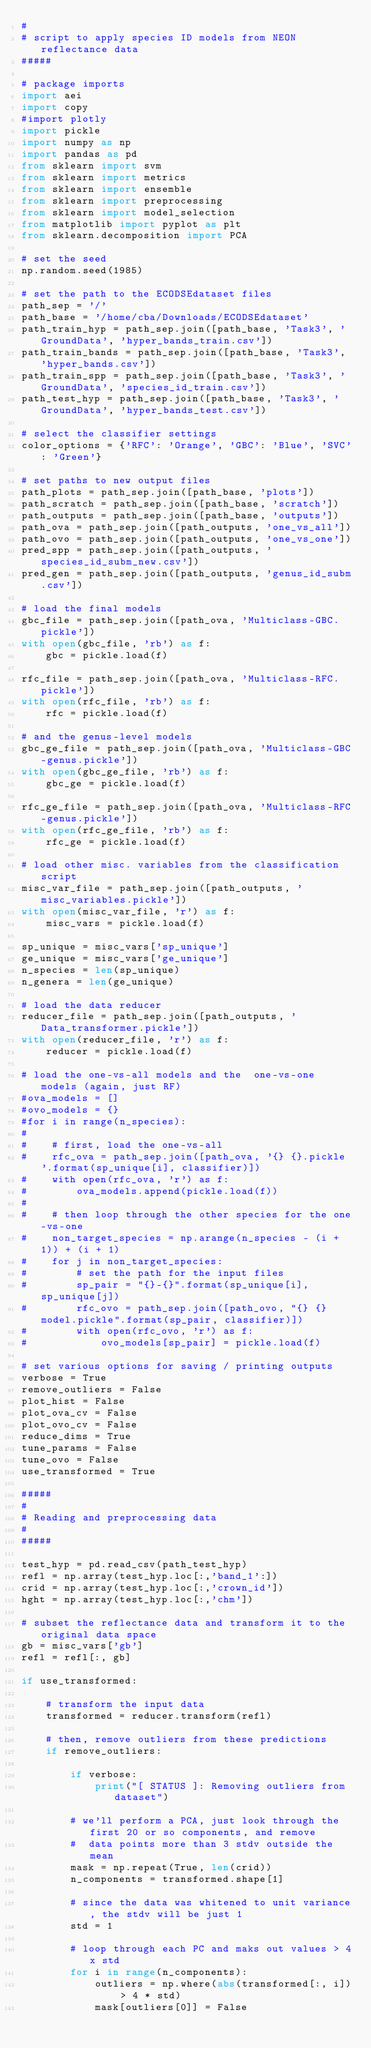Convert code to text. <code><loc_0><loc_0><loc_500><loc_500><_Python_>#
# script to apply species ID models from NEON reflectance data
#####

# package imports
import aei
import copy
#import plotly
import pickle
import numpy as np
import pandas as pd
from sklearn import svm
from sklearn import metrics
from sklearn import ensemble
from sklearn import preprocessing
from sklearn import model_selection
from matplotlib import pyplot as plt
from sklearn.decomposition import PCA

# set the seed
np.random.seed(1985)

# set the path to the ECODSEdataset files
path_sep = '/'
path_base = '/home/cba/Downloads/ECODSEdataset'
path_train_hyp = path_sep.join([path_base, 'Task3', 'GroundData', 'hyper_bands_train.csv'])
path_train_bands = path_sep.join([path_base, 'Task3', 'hyper_bands.csv'])
path_train_spp = path_sep.join([path_base, 'Task3', 'GroundData', 'species_id_train.csv'])
path_test_hyp = path_sep.join([path_base, 'Task3', 'GroundData', 'hyper_bands_test.csv'])

# select the classifier settings
color_options = {'RFC': 'Orange', 'GBC': 'Blue', 'SVC': 'Green'}

# set paths to new output files
path_plots = path_sep.join([path_base, 'plots'])
path_scratch = path_sep.join([path_base, 'scratch'])
path_outputs = path_sep.join([path_base, 'outputs'])
path_ova = path_sep.join([path_outputs, 'one_vs_all'])
path_ovo = path_sep.join([path_outputs, 'one_vs_one'])
pred_spp = path_sep.join([path_outputs, 'species_id_subm_new.csv'])
pred_gen = path_sep.join([path_outputs, 'genus_id_subm.csv'])

# load the final models
gbc_file = path_sep.join([path_ova, 'Multiclass-GBC.pickle'])
with open(gbc_file, 'rb') as f:
    gbc = pickle.load(f)

rfc_file = path_sep.join([path_ova, 'Multiclass-RFC.pickle'])
with open(rfc_file, 'rb') as f:
    rfc = pickle.load(f)
    
# and the genus-level models
gbc_ge_file = path_sep.join([path_ova, 'Multiclass-GBC-genus.pickle'])
with open(gbc_ge_file, 'rb') as f:
    gbc_ge = pickle.load(f)

rfc_ge_file = path_sep.join([path_ova, 'Multiclass-RFC-genus.pickle'])
with open(rfc_ge_file, 'rb') as f:
    rfc_ge = pickle.load(f)
    
# load other misc. variables from the classification script
misc_var_file = path_sep.join([path_outputs, 'misc_variables.pickle'])
with open(misc_var_file, 'r') as f:
    misc_vars = pickle.load(f)
    
sp_unique = misc_vars['sp_unique']
ge_unique = misc_vars['ge_unique']
n_species = len(sp_unique)
n_genera = len(ge_unique)

# load the data reducer
reducer_file = path_sep.join([path_outputs, 'Data_transformer.pickle'])
with open(reducer_file, 'r') as f:
    reducer = pickle.load(f)
    
# load the one-vs-all models and the  one-vs-one models (again, just RF)
#ova_models = []
#ovo_models = {}
#for i in range(n_species):
#    
#    # first, load the one-vs-all
#    rfc_ova = path_sep.join([path_ova, '{} {}.pickle'.format(sp_unique[i], classifier)])
#    with open(rfc_ova, 'r') as f:
#        ova_models.append(pickle.load(f))
#    
#    # then loop through the other species for the one-vs-one
#    non_target_species = np.arange(n_species - (i + 1)) + (i + 1)
#    for j in non_target_species:
#        # set the path for the input files
#        sp_pair = "{}-{}".format(sp_unique[i], sp_unique[j])
#        rfc_ovo = path_sep.join([path_ovo, "{} {} model.pickle".format(sp_pair, classifier)])
#        with open(rfc_ovo, 'r') as f:
#            ovo_models[sp_pair] = pickle.load(f)

# set various options for saving / printing outputs
verbose = True
remove_outliers = False
plot_hist = False
plot_ova_cv = False
plot_ovo_cv = False
reduce_dims = True
tune_params = False
tune_ovo = False
use_transformed = True

#####
#
# Reading and preprocessing data
#
#####

test_hyp = pd.read_csv(path_test_hyp)
refl = np.array(test_hyp.loc[:,'band_1':])
crid = np.array(test_hyp.loc[:,'crown_id'])
hght = np.array(test_hyp.loc[:,'chm'])

# subset the reflectance data and transform it to the original data space
gb = misc_vars['gb']
refl = refl[:, gb]

if use_transformed:
    
    # transform the input data
    transformed = reducer.transform(refl)
    
    # then, remove outliers from these predictions
    if remove_outliers:
        
        if verbose:
            print("[ STATUS ]: Removing outliers from dataset")
        
        # we'll perform a PCA, just look through the first 20 or so components, and remove
        #  data points more than 3 stdv outside the mean
        mask = np.repeat(True, len(crid))
        n_components = transformed.shape[1]
        
        # since the data was whitened to unit variance, the stdv will be just 1
        std = 1
        
        # loop through each PC and maks out values > 4x std
        for i in range(n_components):
            outliers = np.where(abs(transformed[:, i]) > 4 * std)
            mask[outliers[0]] = False
            </code> 